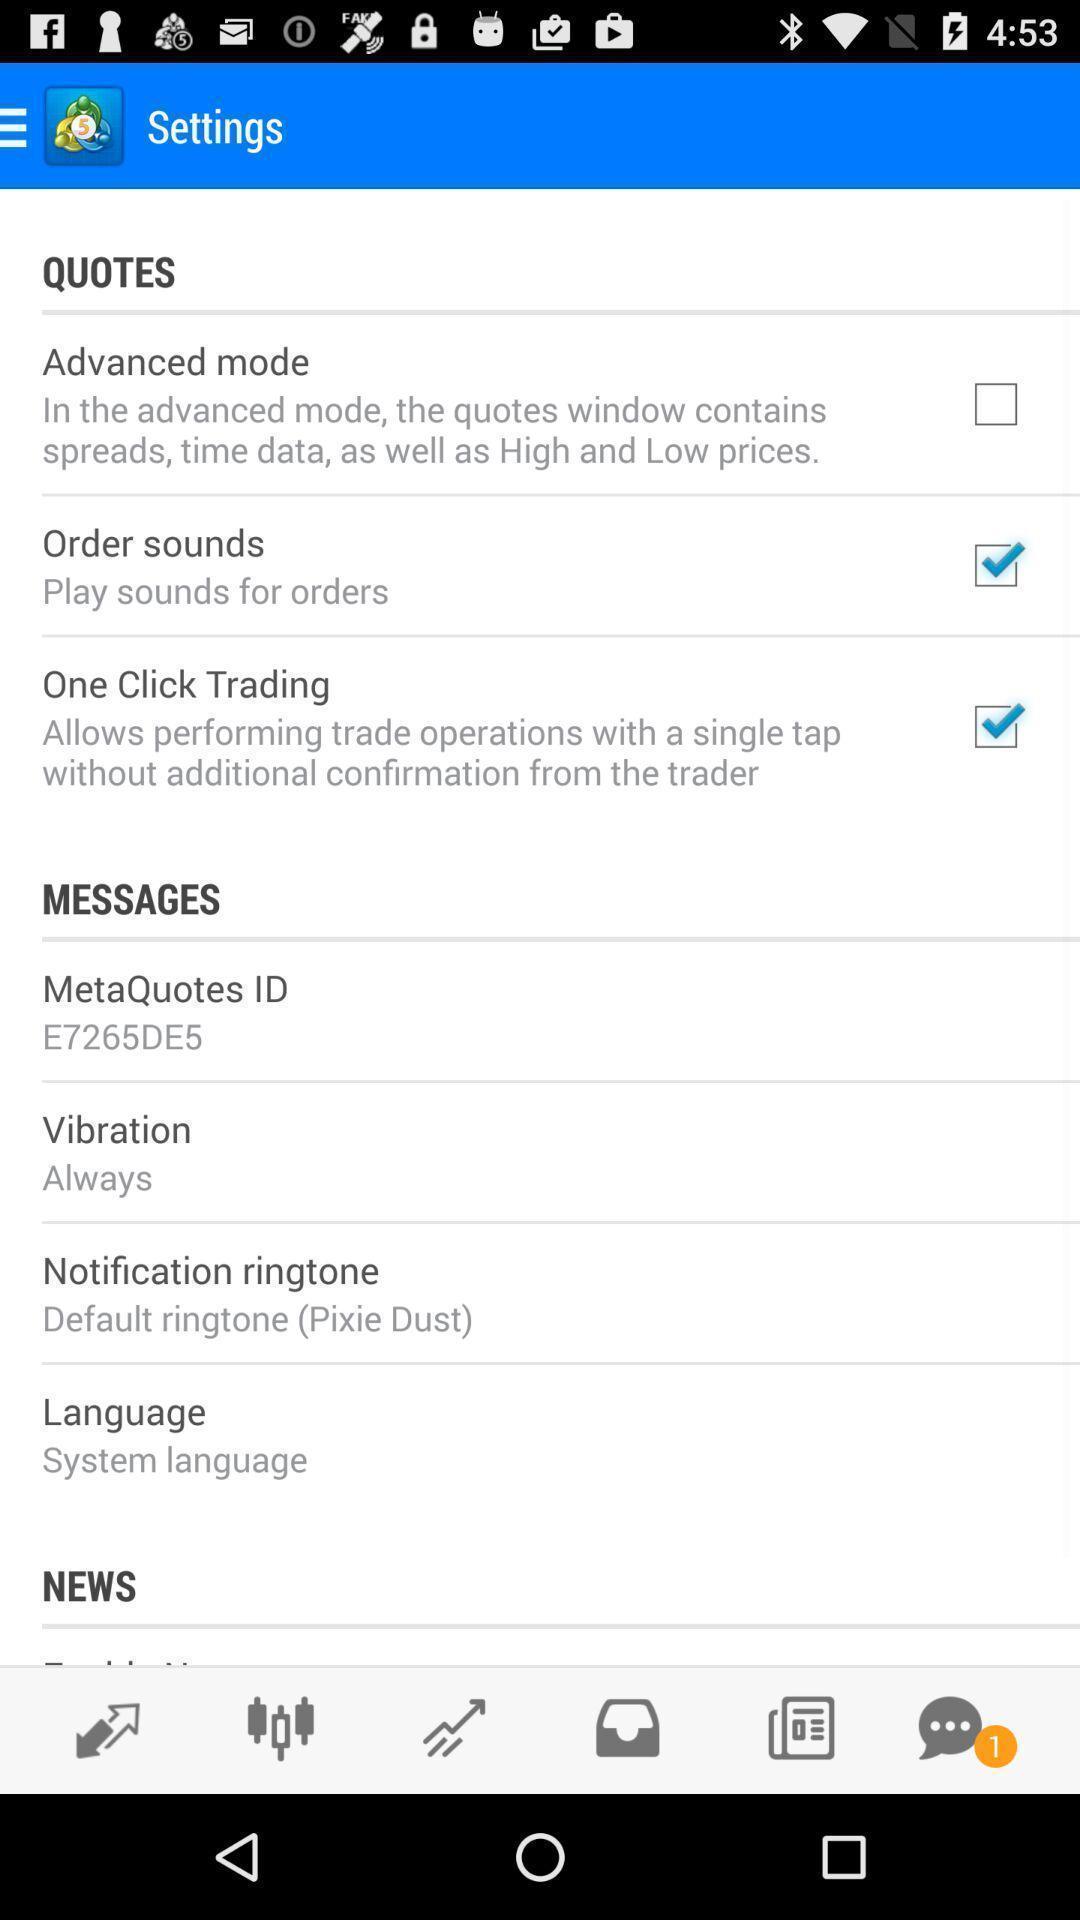Describe this image in words. Settings page of messaging app. 